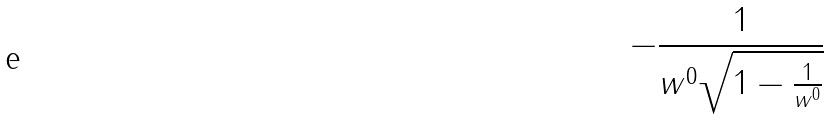Convert formula to latex. <formula><loc_0><loc_0><loc_500><loc_500>- \frac { 1 } { w ^ { 0 } \sqrt { 1 - \frac { 1 } { w ^ { 0 } } } }</formula> 